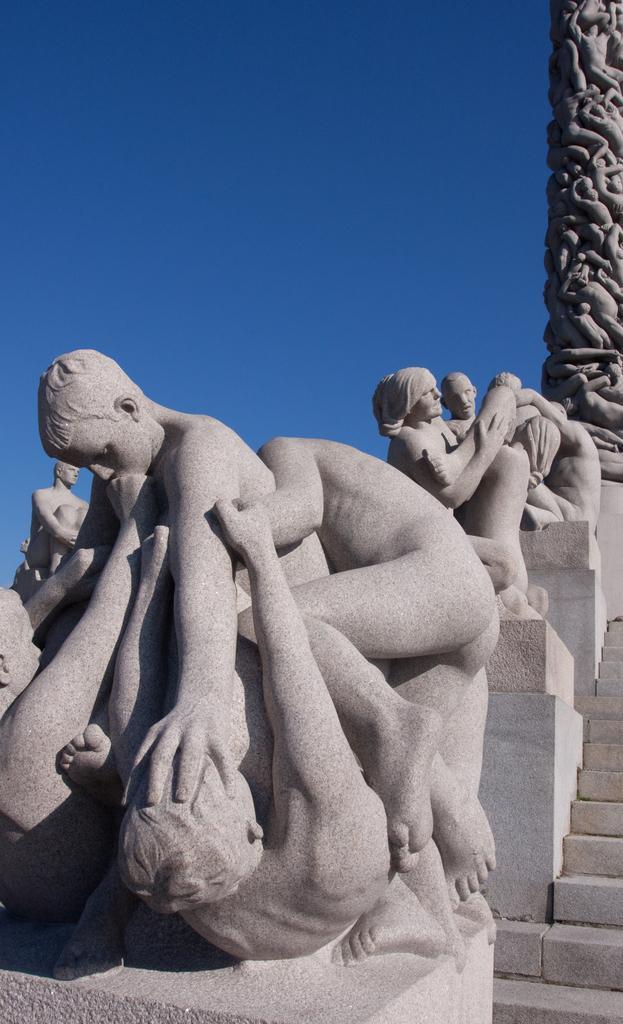Describe this image in one or two sentences. In this picture we can see the sculpture of people, stairs, a pillar and the sky. 